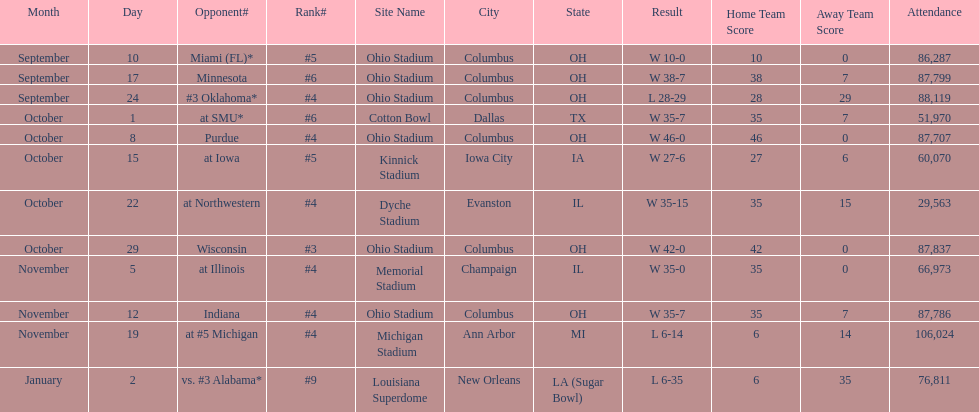Which date was attended by the most people? November 19. 